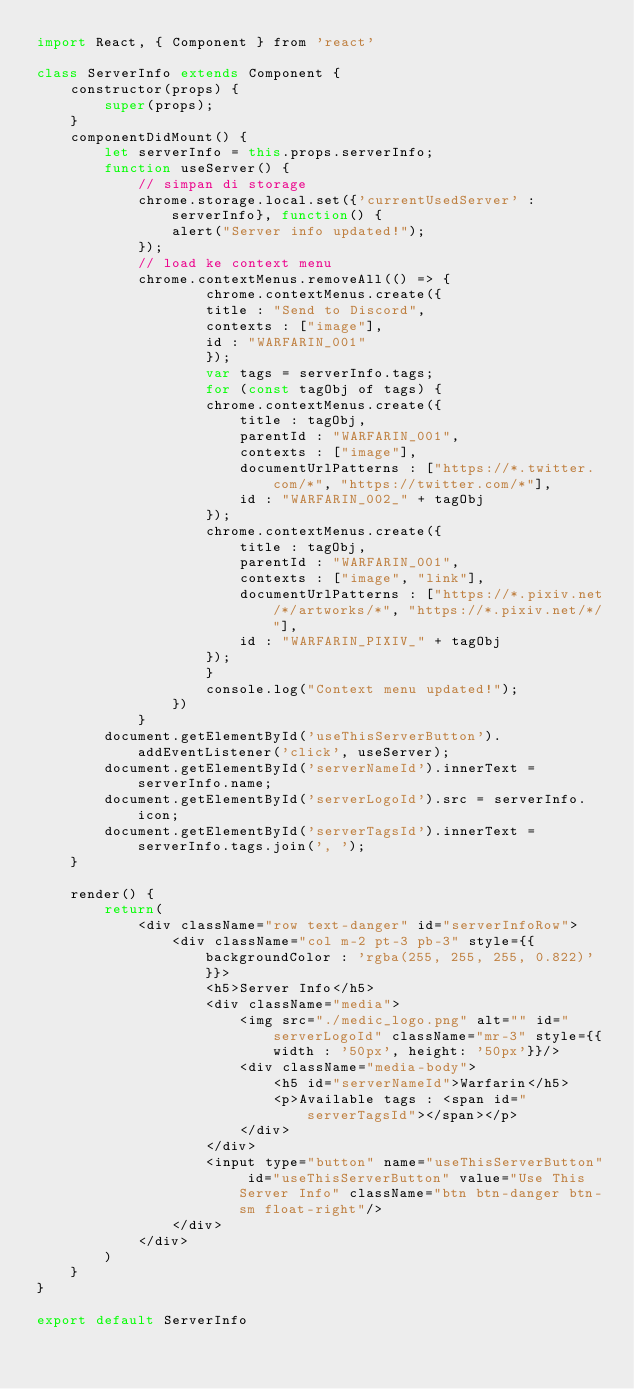Convert code to text. <code><loc_0><loc_0><loc_500><loc_500><_JavaScript_>import React, { Component } from 'react'

class ServerInfo extends Component {
    constructor(props) {
        super(props);
    }
    componentDidMount() {
        let serverInfo = this.props.serverInfo;
        function useServer() {
            // simpan di storage
            chrome.storage.local.set({'currentUsedServer' : serverInfo}, function() {
                alert("Server info updated!");
            });
            // load ke context menu
            chrome.contextMenus.removeAll(() => {
                    chrome.contextMenus.create({
                    title : "Send to Discord",
                    contexts : ["image"],
                    id : "WARFARIN_001"
                    });
                    var tags = serverInfo.tags;
                    for (const tagObj of tags) {
                    chrome.contextMenus.create({
                        title : tagObj,
                        parentId : "WARFARIN_001",
                        contexts : ["image"],
                        documentUrlPatterns : ["https://*.twitter.com/*", "https://twitter.com/*"],
                        id : "WARFARIN_002_" + tagObj
                    });
                    chrome.contextMenus.create({
                        title : tagObj,
                        parentId : "WARFARIN_001",
                        contexts : ["image", "link"],
                        documentUrlPatterns : ["https://*.pixiv.net/*/artworks/*", "https://*.pixiv.net/*/"],
                        id : "WARFARIN_PIXIV_" + tagObj
                    });
                    }
                    console.log("Context menu updated!");            
                })        
            }
        document.getElementById('useThisServerButton').addEventListener('click', useServer);        
        document.getElementById('serverNameId').innerText = serverInfo.name;
        document.getElementById('serverLogoId').src = serverInfo.icon;
        document.getElementById('serverTagsId').innerText = serverInfo.tags.join(', ');
    }

    render() {
        return(
            <div className="row text-danger" id="serverInfoRow">
                <div className="col m-2 pt-3 pb-3" style={{backgroundColor : 'rgba(255, 255, 255, 0.822)'}}>
                    <h5>Server Info</h5>
                    <div className="media">
                        <img src="./medic_logo.png" alt="" id="serverLogoId" className="mr-3" style={{width : '50px', height: '50px'}}/>
                        <div className="media-body">
                            <h5 id="serverNameId">Warfarin</h5>
                            <p>Available tags : <span id="serverTagsId"></span></p>
                        </div>
                    </div>
                    <input type="button" name="useThisServerButton" id="useThisServerButton" value="Use This Server Info" className="btn btn-danger btn-sm float-right"/>
                </div>
            </div>
        )
    }
}

export default ServerInfo</code> 